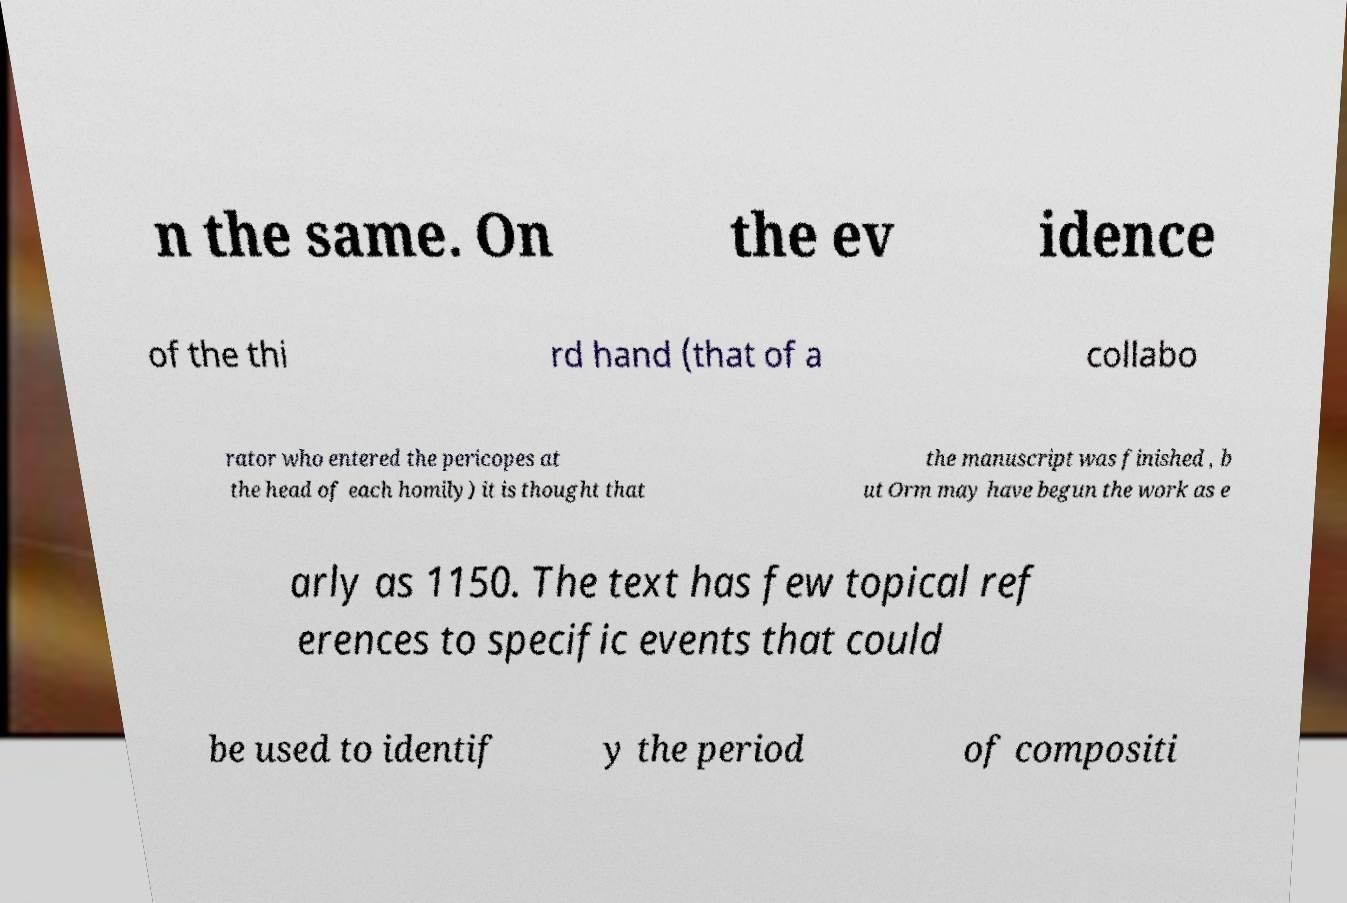For documentation purposes, I need the text within this image transcribed. Could you provide that? n the same. On the ev idence of the thi rd hand (that of a collabo rator who entered the pericopes at the head of each homily) it is thought that the manuscript was finished , b ut Orm may have begun the work as e arly as 1150. The text has few topical ref erences to specific events that could be used to identif y the period of compositi 